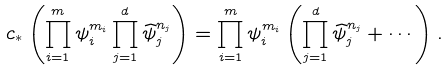Convert formula to latex. <formula><loc_0><loc_0><loc_500><loc_500>c _ { \ast } \left ( \prod _ { i = 1 } ^ { m } \psi _ { i } ^ { m _ { i } } \prod _ { j = 1 } ^ { d } \widehat { \psi } _ { j } ^ { n _ { j } } \right ) = \prod _ { i = 1 } ^ { m } \psi _ { i } ^ { m _ { i } } \left ( \prod _ { j = 1 } ^ { d } \widehat { \psi } _ { j } ^ { n _ { j } } + \cdots \right ) .</formula> 